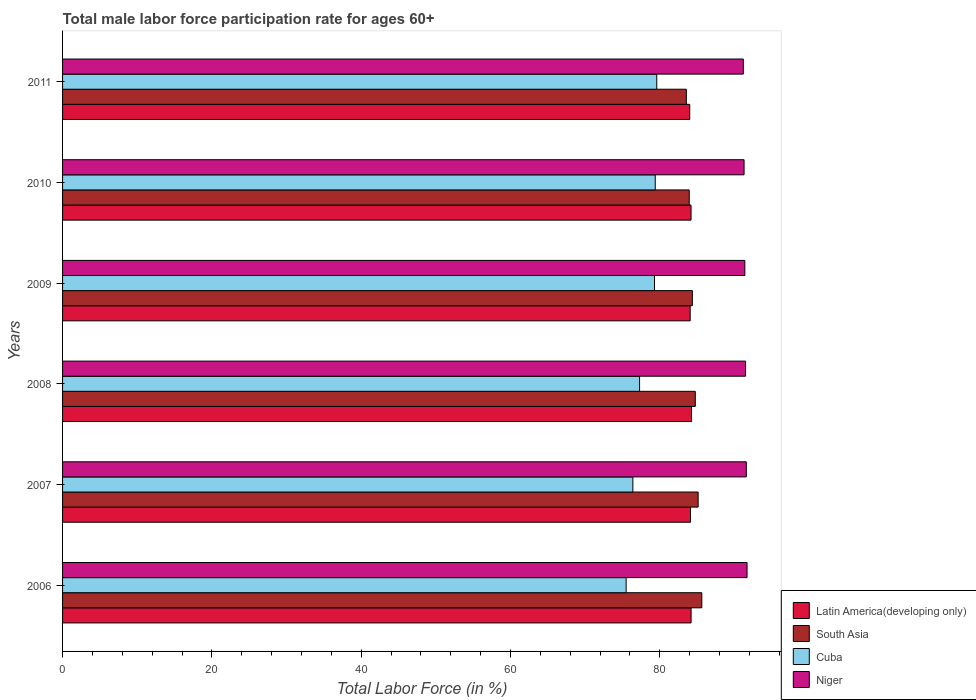Are the number of bars per tick equal to the number of legend labels?
Your answer should be compact. Yes. How many bars are there on the 1st tick from the top?
Offer a very short reply. 4. In how many cases, is the number of bars for a given year not equal to the number of legend labels?
Provide a succinct answer. 0. What is the male labor force participation rate in Latin America(developing only) in 2010?
Ensure brevity in your answer.  84.2. Across all years, what is the maximum male labor force participation rate in Latin America(developing only)?
Your answer should be compact. 84.26. Across all years, what is the minimum male labor force participation rate in Latin America(developing only)?
Give a very brief answer. 84.02. In which year was the male labor force participation rate in Niger minimum?
Your answer should be very brief. 2011. What is the total male labor force participation rate in Cuba in the graph?
Provide a succinct answer. 467.5. What is the difference between the male labor force participation rate in South Asia in 2006 and that in 2007?
Offer a terse response. 0.49. What is the difference between the male labor force participation rate in Latin America(developing only) in 2010 and the male labor force participation rate in Cuba in 2008?
Offer a terse response. 6.9. What is the average male labor force participation rate in Cuba per year?
Offer a very short reply. 77.92. In the year 2009, what is the difference between the male labor force participation rate in Cuba and male labor force participation rate in Latin America(developing only)?
Your answer should be compact. -4.78. What is the ratio of the male labor force participation rate in Niger in 2007 to that in 2010?
Ensure brevity in your answer.  1. Is the male labor force participation rate in South Asia in 2009 less than that in 2010?
Provide a succinct answer. No. Is the difference between the male labor force participation rate in Cuba in 2008 and 2011 greater than the difference between the male labor force participation rate in Latin America(developing only) in 2008 and 2011?
Keep it short and to the point. No. What is the difference between the highest and the second highest male labor force participation rate in Cuba?
Give a very brief answer. 0.2. What is the difference between the highest and the lowest male labor force participation rate in South Asia?
Your answer should be compact. 2.07. In how many years, is the male labor force participation rate in South Asia greater than the average male labor force participation rate in South Asia taken over all years?
Your answer should be very brief. 3. Is it the case that in every year, the sum of the male labor force participation rate in Niger and male labor force participation rate in South Asia is greater than the sum of male labor force participation rate in Latin America(developing only) and male labor force participation rate in Cuba?
Offer a very short reply. Yes. What does the 3rd bar from the top in 2006 represents?
Offer a terse response. South Asia. What does the 1st bar from the bottom in 2011 represents?
Your response must be concise. Latin America(developing only). Are all the bars in the graph horizontal?
Provide a short and direct response. Yes. Does the graph contain any zero values?
Your answer should be compact. No. Where does the legend appear in the graph?
Give a very brief answer. Bottom right. How many legend labels are there?
Your response must be concise. 4. How are the legend labels stacked?
Your answer should be compact. Vertical. What is the title of the graph?
Give a very brief answer. Total male labor force participation rate for ages 60+. Does "Kazakhstan" appear as one of the legend labels in the graph?
Offer a terse response. No. What is the label or title of the Y-axis?
Your response must be concise. Years. What is the Total Labor Force (in %) in Latin America(developing only) in 2006?
Give a very brief answer. 84.2. What is the Total Labor Force (in %) in South Asia in 2006?
Offer a very short reply. 85.64. What is the Total Labor Force (in %) in Cuba in 2006?
Your answer should be very brief. 75.5. What is the Total Labor Force (in %) of Niger in 2006?
Ensure brevity in your answer.  91.7. What is the Total Labor Force (in %) in Latin America(developing only) in 2007?
Give a very brief answer. 84.13. What is the Total Labor Force (in %) in South Asia in 2007?
Provide a short and direct response. 85.14. What is the Total Labor Force (in %) of Cuba in 2007?
Keep it short and to the point. 76.4. What is the Total Labor Force (in %) in Niger in 2007?
Give a very brief answer. 91.6. What is the Total Labor Force (in %) of Latin America(developing only) in 2008?
Your response must be concise. 84.26. What is the Total Labor Force (in %) of South Asia in 2008?
Make the answer very short. 84.77. What is the Total Labor Force (in %) of Cuba in 2008?
Offer a terse response. 77.3. What is the Total Labor Force (in %) in Niger in 2008?
Make the answer very short. 91.5. What is the Total Labor Force (in %) of Latin America(developing only) in 2009?
Keep it short and to the point. 84.08. What is the Total Labor Force (in %) of South Asia in 2009?
Your response must be concise. 84.37. What is the Total Labor Force (in %) in Cuba in 2009?
Offer a very short reply. 79.3. What is the Total Labor Force (in %) of Niger in 2009?
Provide a short and direct response. 91.4. What is the Total Labor Force (in %) of Latin America(developing only) in 2010?
Offer a terse response. 84.2. What is the Total Labor Force (in %) in South Asia in 2010?
Provide a succinct answer. 83.95. What is the Total Labor Force (in %) of Cuba in 2010?
Keep it short and to the point. 79.4. What is the Total Labor Force (in %) in Niger in 2010?
Offer a terse response. 91.3. What is the Total Labor Force (in %) in Latin America(developing only) in 2011?
Your answer should be compact. 84.02. What is the Total Labor Force (in %) in South Asia in 2011?
Offer a terse response. 83.57. What is the Total Labor Force (in %) of Cuba in 2011?
Provide a succinct answer. 79.6. What is the Total Labor Force (in %) of Niger in 2011?
Give a very brief answer. 91.2. Across all years, what is the maximum Total Labor Force (in %) of Latin America(developing only)?
Your answer should be compact. 84.26. Across all years, what is the maximum Total Labor Force (in %) of South Asia?
Keep it short and to the point. 85.64. Across all years, what is the maximum Total Labor Force (in %) of Cuba?
Offer a terse response. 79.6. Across all years, what is the maximum Total Labor Force (in %) of Niger?
Give a very brief answer. 91.7. Across all years, what is the minimum Total Labor Force (in %) of Latin America(developing only)?
Your answer should be compact. 84.02. Across all years, what is the minimum Total Labor Force (in %) of South Asia?
Your answer should be compact. 83.57. Across all years, what is the minimum Total Labor Force (in %) of Cuba?
Offer a terse response. 75.5. Across all years, what is the minimum Total Labor Force (in %) in Niger?
Your answer should be very brief. 91.2. What is the total Total Labor Force (in %) in Latin America(developing only) in the graph?
Provide a succinct answer. 504.88. What is the total Total Labor Force (in %) in South Asia in the graph?
Offer a terse response. 507.44. What is the total Total Labor Force (in %) in Cuba in the graph?
Ensure brevity in your answer.  467.5. What is the total Total Labor Force (in %) in Niger in the graph?
Ensure brevity in your answer.  548.7. What is the difference between the Total Labor Force (in %) in Latin America(developing only) in 2006 and that in 2007?
Offer a very short reply. 0.08. What is the difference between the Total Labor Force (in %) in South Asia in 2006 and that in 2007?
Make the answer very short. 0.49. What is the difference between the Total Labor Force (in %) of Cuba in 2006 and that in 2007?
Offer a terse response. -0.9. What is the difference between the Total Labor Force (in %) of Niger in 2006 and that in 2007?
Provide a short and direct response. 0.1. What is the difference between the Total Labor Force (in %) in Latin America(developing only) in 2006 and that in 2008?
Your response must be concise. -0.05. What is the difference between the Total Labor Force (in %) in South Asia in 2006 and that in 2008?
Keep it short and to the point. 0.87. What is the difference between the Total Labor Force (in %) in Latin America(developing only) in 2006 and that in 2009?
Offer a very short reply. 0.12. What is the difference between the Total Labor Force (in %) of South Asia in 2006 and that in 2009?
Offer a very short reply. 1.27. What is the difference between the Total Labor Force (in %) of Latin America(developing only) in 2006 and that in 2010?
Your answer should be compact. 0.01. What is the difference between the Total Labor Force (in %) of South Asia in 2006 and that in 2010?
Keep it short and to the point. 1.68. What is the difference between the Total Labor Force (in %) of Cuba in 2006 and that in 2010?
Provide a short and direct response. -3.9. What is the difference between the Total Labor Force (in %) in Latin America(developing only) in 2006 and that in 2011?
Provide a short and direct response. 0.18. What is the difference between the Total Labor Force (in %) of South Asia in 2006 and that in 2011?
Offer a terse response. 2.07. What is the difference between the Total Labor Force (in %) in Niger in 2006 and that in 2011?
Your answer should be compact. 0.5. What is the difference between the Total Labor Force (in %) of Latin America(developing only) in 2007 and that in 2008?
Provide a succinct answer. -0.13. What is the difference between the Total Labor Force (in %) of South Asia in 2007 and that in 2008?
Offer a terse response. 0.38. What is the difference between the Total Labor Force (in %) in Cuba in 2007 and that in 2008?
Your response must be concise. -0.9. What is the difference between the Total Labor Force (in %) of Latin America(developing only) in 2007 and that in 2009?
Provide a short and direct response. 0.05. What is the difference between the Total Labor Force (in %) of South Asia in 2007 and that in 2009?
Your answer should be very brief. 0.77. What is the difference between the Total Labor Force (in %) in Cuba in 2007 and that in 2009?
Make the answer very short. -2.9. What is the difference between the Total Labor Force (in %) in Niger in 2007 and that in 2009?
Make the answer very short. 0.2. What is the difference between the Total Labor Force (in %) of Latin America(developing only) in 2007 and that in 2010?
Provide a succinct answer. -0.07. What is the difference between the Total Labor Force (in %) of South Asia in 2007 and that in 2010?
Your response must be concise. 1.19. What is the difference between the Total Labor Force (in %) in Niger in 2007 and that in 2010?
Your answer should be very brief. 0.3. What is the difference between the Total Labor Force (in %) in Latin America(developing only) in 2007 and that in 2011?
Keep it short and to the point. 0.11. What is the difference between the Total Labor Force (in %) in South Asia in 2007 and that in 2011?
Make the answer very short. 1.58. What is the difference between the Total Labor Force (in %) in Cuba in 2007 and that in 2011?
Your answer should be very brief. -3.2. What is the difference between the Total Labor Force (in %) of Latin America(developing only) in 2008 and that in 2009?
Give a very brief answer. 0.18. What is the difference between the Total Labor Force (in %) in South Asia in 2008 and that in 2009?
Your response must be concise. 0.39. What is the difference between the Total Labor Force (in %) of Cuba in 2008 and that in 2009?
Give a very brief answer. -2. What is the difference between the Total Labor Force (in %) in Niger in 2008 and that in 2009?
Give a very brief answer. 0.1. What is the difference between the Total Labor Force (in %) of Latin America(developing only) in 2008 and that in 2010?
Make the answer very short. 0.06. What is the difference between the Total Labor Force (in %) in South Asia in 2008 and that in 2010?
Offer a terse response. 0.81. What is the difference between the Total Labor Force (in %) in Cuba in 2008 and that in 2010?
Provide a short and direct response. -2.1. What is the difference between the Total Labor Force (in %) of Niger in 2008 and that in 2010?
Ensure brevity in your answer.  0.2. What is the difference between the Total Labor Force (in %) of Latin America(developing only) in 2008 and that in 2011?
Your response must be concise. 0.24. What is the difference between the Total Labor Force (in %) in South Asia in 2008 and that in 2011?
Offer a terse response. 1.2. What is the difference between the Total Labor Force (in %) in Niger in 2008 and that in 2011?
Make the answer very short. 0.3. What is the difference between the Total Labor Force (in %) of Latin America(developing only) in 2009 and that in 2010?
Ensure brevity in your answer.  -0.12. What is the difference between the Total Labor Force (in %) of South Asia in 2009 and that in 2010?
Your answer should be compact. 0.42. What is the difference between the Total Labor Force (in %) in Cuba in 2009 and that in 2010?
Make the answer very short. -0.1. What is the difference between the Total Labor Force (in %) of Latin America(developing only) in 2009 and that in 2011?
Your response must be concise. 0.06. What is the difference between the Total Labor Force (in %) in South Asia in 2009 and that in 2011?
Keep it short and to the point. 0.8. What is the difference between the Total Labor Force (in %) in Latin America(developing only) in 2010 and that in 2011?
Offer a terse response. 0.18. What is the difference between the Total Labor Force (in %) of South Asia in 2010 and that in 2011?
Your answer should be very brief. 0.39. What is the difference between the Total Labor Force (in %) in Niger in 2010 and that in 2011?
Offer a terse response. 0.1. What is the difference between the Total Labor Force (in %) in Latin America(developing only) in 2006 and the Total Labor Force (in %) in South Asia in 2007?
Provide a succinct answer. -0.94. What is the difference between the Total Labor Force (in %) of Latin America(developing only) in 2006 and the Total Labor Force (in %) of Cuba in 2007?
Keep it short and to the point. 7.8. What is the difference between the Total Labor Force (in %) in Latin America(developing only) in 2006 and the Total Labor Force (in %) in Niger in 2007?
Give a very brief answer. -7.4. What is the difference between the Total Labor Force (in %) in South Asia in 2006 and the Total Labor Force (in %) in Cuba in 2007?
Give a very brief answer. 9.24. What is the difference between the Total Labor Force (in %) of South Asia in 2006 and the Total Labor Force (in %) of Niger in 2007?
Your answer should be compact. -5.96. What is the difference between the Total Labor Force (in %) of Cuba in 2006 and the Total Labor Force (in %) of Niger in 2007?
Offer a terse response. -16.1. What is the difference between the Total Labor Force (in %) in Latin America(developing only) in 2006 and the Total Labor Force (in %) in South Asia in 2008?
Make the answer very short. -0.56. What is the difference between the Total Labor Force (in %) of Latin America(developing only) in 2006 and the Total Labor Force (in %) of Cuba in 2008?
Your answer should be compact. 6.9. What is the difference between the Total Labor Force (in %) in Latin America(developing only) in 2006 and the Total Labor Force (in %) in Niger in 2008?
Give a very brief answer. -7.3. What is the difference between the Total Labor Force (in %) of South Asia in 2006 and the Total Labor Force (in %) of Cuba in 2008?
Keep it short and to the point. 8.34. What is the difference between the Total Labor Force (in %) in South Asia in 2006 and the Total Labor Force (in %) in Niger in 2008?
Your answer should be compact. -5.86. What is the difference between the Total Labor Force (in %) in Cuba in 2006 and the Total Labor Force (in %) in Niger in 2008?
Provide a succinct answer. -16. What is the difference between the Total Labor Force (in %) of Latin America(developing only) in 2006 and the Total Labor Force (in %) of South Asia in 2009?
Ensure brevity in your answer.  -0.17. What is the difference between the Total Labor Force (in %) in Latin America(developing only) in 2006 and the Total Labor Force (in %) in Cuba in 2009?
Provide a short and direct response. 4.9. What is the difference between the Total Labor Force (in %) of Latin America(developing only) in 2006 and the Total Labor Force (in %) of Niger in 2009?
Keep it short and to the point. -7.2. What is the difference between the Total Labor Force (in %) of South Asia in 2006 and the Total Labor Force (in %) of Cuba in 2009?
Give a very brief answer. 6.34. What is the difference between the Total Labor Force (in %) in South Asia in 2006 and the Total Labor Force (in %) in Niger in 2009?
Ensure brevity in your answer.  -5.76. What is the difference between the Total Labor Force (in %) in Cuba in 2006 and the Total Labor Force (in %) in Niger in 2009?
Ensure brevity in your answer.  -15.9. What is the difference between the Total Labor Force (in %) of Latin America(developing only) in 2006 and the Total Labor Force (in %) of South Asia in 2010?
Your answer should be compact. 0.25. What is the difference between the Total Labor Force (in %) of Latin America(developing only) in 2006 and the Total Labor Force (in %) of Cuba in 2010?
Keep it short and to the point. 4.8. What is the difference between the Total Labor Force (in %) of Latin America(developing only) in 2006 and the Total Labor Force (in %) of Niger in 2010?
Your response must be concise. -7.1. What is the difference between the Total Labor Force (in %) in South Asia in 2006 and the Total Labor Force (in %) in Cuba in 2010?
Give a very brief answer. 6.24. What is the difference between the Total Labor Force (in %) in South Asia in 2006 and the Total Labor Force (in %) in Niger in 2010?
Offer a very short reply. -5.66. What is the difference between the Total Labor Force (in %) of Cuba in 2006 and the Total Labor Force (in %) of Niger in 2010?
Your response must be concise. -15.8. What is the difference between the Total Labor Force (in %) in Latin America(developing only) in 2006 and the Total Labor Force (in %) in South Asia in 2011?
Make the answer very short. 0.64. What is the difference between the Total Labor Force (in %) in Latin America(developing only) in 2006 and the Total Labor Force (in %) in Cuba in 2011?
Your answer should be very brief. 4.6. What is the difference between the Total Labor Force (in %) of Latin America(developing only) in 2006 and the Total Labor Force (in %) of Niger in 2011?
Offer a very short reply. -7. What is the difference between the Total Labor Force (in %) in South Asia in 2006 and the Total Labor Force (in %) in Cuba in 2011?
Offer a terse response. 6.04. What is the difference between the Total Labor Force (in %) of South Asia in 2006 and the Total Labor Force (in %) of Niger in 2011?
Offer a terse response. -5.56. What is the difference between the Total Labor Force (in %) of Cuba in 2006 and the Total Labor Force (in %) of Niger in 2011?
Offer a very short reply. -15.7. What is the difference between the Total Labor Force (in %) of Latin America(developing only) in 2007 and the Total Labor Force (in %) of South Asia in 2008?
Your answer should be very brief. -0.64. What is the difference between the Total Labor Force (in %) in Latin America(developing only) in 2007 and the Total Labor Force (in %) in Cuba in 2008?
Provide a short and direct response. 6.83. What is the difference between the Total Labor Force (in %) of Latin America(developing only) in 2007 and the Total Labor Force (in %) of Niger in 2008?
Ensure brevity in your answer.  -7.37. What is the difference between the Total Labor Force (in %) in South Asia in 2007 and the Total Labor Force (in %) in Cuba in 2008?
Keep it short and to the point. 7.84. What is the difference between the Total Labor Force (in %) of South Asia in 2007 and the Total Labor Force (in %) of Niger in 2008?
Provide a succinct answer. -6.36. What is the difference between the Total Labor Force (in %) in Cuba in 2007 and the Total Labor Force (in %) in Niger in 2008?
Give a very brief answer. -15.1. What is the difference between the Total Labor Force (in %) of Latin America(developing only) in 2007 and the Total Labor Force (in %) of South Asia in 2009?
Ensure brevity in your answer.  -0.25. What is the difference between the Total Labor Force (in %) of Latin America(developing only) in 2007 and the Total Labor Force (in %) of Cuba in 2009?
Give a very brief answer. 4.83. What is the difference between the Total Labor Force (in %) in Latin America(developing only) in 2007 and the Total Labor Force (in %) in Niger in 2009?
Offer a terse response. -7.27. What is the difference between the Total Labor Force (in %) of South Asia in 2007 and the Total Labor Force (in %) of Cuba in 2009?
Make the answer very short. 5.84. What is the difference between the Total Labor Force (in %) of South Asia in 2007 and the Total Labor Force (in %) of Niger in 2009?
Provide a short and direct response. -6.25. What is the difference between the Total Labor Force (in %) of Latin America(developing only) in 2007 and the Total Labor Force (in %) of South Asia in 2010?
Provide a short and direct response. 0.17. What is the difference between the Total Labor Force (in %) in Latin America(developing only) in 2007 and the Total Labor Force (in %) in Cuba in 2010?
Offer a terse response. 4.73. What is the difference between the Total Labor Force (in %) in Latin America(developing only) in 2007 and the Total Labor Force (in %) in Niger in 2010?
Ensure brevity in your answer.  -7.17. What is the difference between the Total Labor Force (in %) in South Asia in 2007 and the Total Labor Force (in %) in Cuba in 2010?
Keep it short and to the point. 5.75. What is the difference between the Total Labor Force (in %) of South Asia in 2007 and the Total Labor Force (in %) of Niger in 2010?
Offer a terse response. -6.16. What is the difference between the Total Labor Force (in %) in Cuba in 2007 and the Total Labor Force (in %) in Niger in 2010?
Keep it short and to the point. -14.9. What is the difference between the Total Labor Force (in %) of Latin America(developing only) in 2007 and the Total Labor Force (in %) of South Asia in 2011?
Ensure brevity in your answer.  0.56. What is the difference between the Total Labor Force (in %) of Latin America(developing only) in 2007 and the Total Labor Force (in %) of Cuba in 2011?
Keep it short and to the point. 4.53. What is the difference between the Total Labor Force (in %) in Latin America(developing only) in 2007 and the Total Labor Force (in %) in Niger in 2011?
Provide a succinct answer. -7.07. What is the difference between the Total Labor Force (in %) of South Asia in 2007 and the Total Labor Force (in %) of Cuba in 2011?
Your answer should be very brief. 5.54. What is the difference between the Total Labor Force (in %) of South Asia in 2007 and the Total Labor Force (in %) of Niger in 2011?
Your answer should be very brief. -6.05. What is the difference between the Total Labor Force (in %) of Cuba in 2007 and the Total Labor Force (in %) of Niger in 2011?
Make the answer very short. -14.8. What is the difference between the Total Labor Force (in %) of Latin America(developing only) in 2008 and the Total Labor Force (in %) of South Asia in 2009?
Offer a very short reply. -0.11. What is the difference between the Total Labor Force (in %) in Latin America(developing only) in 2008 and the Total Labor Force (in %) in Cuba in 2009?
Give a very brief answer. 4.96. What is the difference between the Total Labor Force (in %) of Latin America(developing only) in 2008 and the Total Labor Force (in %) of Niger in 2009?
Make the answer very short. -7.14. What is the difference between the Total Labor Force (in %) in South Asia in 2008 and the Total Labor Force (in %) in Cuba in 2009?
Make the answer very short. 5.47. What is the difference between the Total Labor Force (in %) in South Asia in 2008 and the Total Labor Force (in %) in Niger in 2009?
Make the answer very short. -6.63. What is the difference between the Total Labor Force (in %) of Cuba in 2008 and the Total Labor Force (in %) of Niger in 2009?
Your answer should be compact. -14.1. What is the difference between the Total Labor Force (in %) in Latin America(developing only) in 2008 and the Total Labor Force (in %) in South Asia in 2010?
Keep it short and to the point. 0.3. What is the difference between the Total Labor Force (in %) in Latin America(developing only) in 2008 and the Total Labor Force (in %) in Cuba in 2010?
Make the answer very short. 4.86. What is the difference between the Total Labor Force (in %) in Latin America(developing only) in 2008 and the Total Labor Force (in %) in Niger in 2010?
Your answer should be compact. -7.04. What is the difference between the Total Labor Force (in %) of South Asia in 2008 and the Total Labor Force (in %) of Cuba in 2010?
Provide a succinct answer. 5.37. What is the difference between the Total Labor Force (in %) in South Asia in 2008 and the Total Labor Force (in %) in Niger in 2010?
Your answer should be very brief. -6.53. What is the difference between the Total Labor Force (in %) of Latin America(developing only) in 2008 and the Total Labor Force (in %) of South Asia in 2011?
Your answer should be compact. 0.69. What is the difference between the Total Labor Force (in %) of Latin America(developing only) in 2008 and the Total Labor Force (in %) of Cuba in 2011?
Your answer should be very brief. 4.66. What is the difference between the Total Labor Force (in %) in Latin America(developing only) in 2008 and the Total Labor Force (in %) in Niger in 2011?
Provide a succinct answer. -6.94. What is the difference between the Total Labor Force (in %) of South Asia in 2008 and the Total Labor Force (in %) of Cuba in 2011?
Your response must be concise. 5.17. What is the difference between the Total Labor Force (in %) in South Asia in 2008 and the Total Labor Force (in %) in Niger in 2011?
Keep it short and to the point. -6.43. What is the difference between the Total Labor Force (in %) of Latin America(developing only) in 2009 and the Total Labor Force (in %) of South Asia in 2010?
Your answer should be compact. 0.13. What is the difference between the Total Labor Force (in %) in Latin America(developing only) in 2009 and the Total Labor Force (in %) in Cuba in 2010?
Offer a terse response. 4.68. What is the difference between the Total Labor Force (in %) of Latin America(developing only) in 2009 and the Total Labor Force (in %) of Niger in 2010?
Your answer should be very brief. -7.22. What is the difference between the Total Labor Force (in %) of South Asia in 2009 and the Total Labor Force (in %) of Cuba in 2010?
Ensure brevity in your answer.  4.97. What is the difference between the Total Labor Force (in %) of South Asia in 2009 and the Total Labor Force (in %) of Niger in 2010?
Ensure brevity in your answer.  -6.93. What is the difference between the Total Labor Force (in %) in Cuba in 2009 and the Total Labor Force (in %) in Niger in 2010?
Offer a terse response. -12. What is the difference between the Total Labor Force (in %) in Latin America(developing only) in 2009 and the Total Labor Force (in %) in South Asia in 2011?
Your answer should be compact. 0.51. What is the difference between the Total Labor Force (in %) of Latin America(developing only) in 2009 and the Total Labor Force (in %) of Cuba in 2011?
Give a very brief answer. 4.48. What is the difference between the Total Labor Force (in %) of Latin America(developing only) in 2009 and the Total Labor Force (in %) of Niger in 2011?
Provide a succinct answer. -7.12. What is the difference between the Total Labor Force (in %) in South Asia in 2009 and the Total Labor Force (in %) in Cuba in 2011?
Make the answer very short. 4.77. What is the difference between the Total Labor Force (in %) in South Asia in 2009 and the Total Labor Force (in %) in Niger in 2011?
Your answer should be compact. -6.83. What is the difference between the Total Labor Force (in %) of Latin America(developing only) in 2010 and the Total Labor Force (in %) of South Asia in 2011?
Give a very brief answer. 0.63. What is the difference between the Total Labor Force (in %) of Latin America(developing only) in 2010 and the Total Labor Force (in %) of Cuba in 2011?
Offer a terse response. 4.6. What is the difference between the Total Labor Force (in %) in Latin America(developing only) in 2010 and the Total Labor Force (in %) in Niger in 2011?
Offer a terse response. -7. What is the difference between the Total Labor Force (in %) in South Asia in 2010 and the Total Labor Force (in %) in Cuba in 2011?
Offer a terse response. 4.35. What is the difference between the Total Labor Force (in %) of South Asia in 2010 and the Total Labor Force (in %) of Niger in 2011?
Your answer should be very brief. -7.25. What is the difference between the Total Labor Force (in %) of Cuba in 2010 and the Total Labor Force (in %) of Niger in 2011?
Give a very brief answer. -11.8. What is the average Total Labor Force (in %) in Latin America(developing only) per year?
Offer a terse response. 84.15. What is the average Total Labor Force (in %) of South Asia per year?
Make the answer very short. 84.57. What is the average Total Labor Force (in %) of Cuba per year?
Keep it short and to the point. 77.92. What is the average Total Labor Force (in %) in Niger per year?
Keep it short and to the point. 91.45. In the year 2006, what is the difference between the Total Labor Force (in %) of Latin America(developing only) and Total Labor Force (in %) of South Asia?
Ensure brevity in your answer.  -1.43. In the year 2006, what is the difference between the Total Labor Force (in %) of Latin America(developing only) and Total Labor Force (in %) of Cuba?
Your answer should be very brief. 8.7. In the year 2006, what is the difference between the Total Labor Force (in %) in Latin America(developing only) and Total Labor Force (in %) in Niger?
Give a very brief answer. -7.5. In the year 2006, what is the difference between the Total Labor Force (in %) of South Asia and Total Labor Force (in %) of Cuba?
Give a very brief answer. 10.14. In the year 2006, what is the difference between the Total Labor Force (in %) of South Asia and Total Labor Force (in %) of Niger?
Keep it short and to the point. -6.06. In the year 2006, what is the difference between the Total Labor Force (in %) in Cuba and Total Labor Force (in %) in Niger?
Your answer should be very brief. -16.2. In the year 2007, what is the difference between the Total Labor Force (in %) in Latin America(developing only) and Total Labor Force (in %) in South Asia?
Keep it short and to the point. -1.02. In the year 2007, what is the difference between the Total Labor Force (in %) of Latin America(developing only) and Total Labor Force (in %) of Cuba?
Your answer should be compact. 7.73. In the year 2007, what is the difference between the Total Labor Force (in %) of Latin America(developing only) and Total Labor Force (in %) of Niger?
Give a very brief answer. -7.47. In the year 2007, what is the difference between the Total Labor Force (in %) in South Asia and Total Labor Force (in %) in Cuba?
Provide a succinct answer. 8.74. In the year 2007, what is the difference between the Total Labor Force (in %) of South Asia and Total Labor Force (in %) of Niger?
Offer a very short reply. -6.46. In the year 2007, what is the difference between the Total Labor Force (in %) in Cuba and Total Labor Force (in %) in Niger?
Provide a short and direct response. -15.2. In the year 2008, what is the difference between the Total Labor Force (in %) in Latin America(developing only) and Total Labor Force (in %) in South Asia?
Provide a succinct answer. -0.51. In the year 2008, what is the difference between the Total Labor Force (in %) of Latin America(developing only) and Total Labor Force (in %) of Cuba?
Make the answer very short. 6.96. In the year 2008, what is the difference between the Total Labor Force (in %) in Latin America(developing only) and Total Labor Force (in %) in Niger?
Keep it short and to the point. -7.24. In the year 2008, what is the difference between the Total Labor Force (in %) in South Asia and Total Labor Force (in %) in Cuba?
Offer a terse response. 7.47. In the year 2008, what is the difference between the Total Labor Force (in %) in South Asia and Total Labor Force (in %) in Niger?
Offer a terse response. -6.73. In the year 2009, what is the difference between the Total Labor Force (in %) in Latin America(developing only) and Total Labor Force (in %) in South Asia?
Keep it short and to the point. -0.29. In the year 2009, what is the difference between the Total Labor Force (in %) of Latin America(developing only) and Total Labor Force (in %) of Cuba?
Your response must be concise. 4.78. In the year 2009, what is the difference between the Total Labor Force (in %) in Latin America(developing only) and Total Labor Force (in %) in Niger?
Ensure brevity in your answer.  -7.32. In the year 2009, what is the difference between the Total Labor Force (in %) of South Asia and Total Labor Force (in %) of Cuba?
Offer a terse response. 5.07. In the year 2009, what is the difference between the Total Labor Force (in %) in South Asia and Total Labor Force (in %) in Niger?
Your response must be concise. -7.03. In the year 2009, what is the difference between the Total Labor Force (in %) in Cuba and Total Labor Force (in %) in Niger?
Give a very brief answer. -12.1. In the year 2010, what is the difference between the Total Labor Force (in %) in Latin America(developing only) and Total Labor Force (in %) in South Asia?
Make the answer very short. 0.24. In the year 2010, what is the difference between the Total Labor Force (in %) in Latin America(developing only) and Total Labor Force (in %) in Cuba?
Give a very brief answer. 4.8. In the year 2010, what is the difference between the Total Labor Force (in %) of Latin America(developing only) and Total Labor Force (in %) of Niger?
Provide a succinct answer. -7.1. In the year 2010, what is the difference between the Total Labor Force (in %) in South Asia and Total Labor Force (in %) in Cuba?
Your answer should be compact. 4.55. In the year 2010, what is the difference between the Total Labor Force (in %) in South Asia and Total Labor Force (in %) in Niger?
Your response must be concise. -7.35. In the year 2011, what is the difference between the Total Labor Force (in %) of Latin America(developing only) and Total Labor Force (in %) of South Asia?
Offer a terse response. 0.45. In the year 2011, what is the difference between the Total Labor Force (in %) in Latin America(developing only) and Total Labor Force (in %) in Cuba?
Provide a succinct answer. 4.42. In the year 2011, what is the difference between the Total Labor Force (in %) in Latin America(developing only) and Total Labor Force (in %) in Niger?
Your answer should be compact. -7.18. In the year 2011, what is the difference between the Total Labor Force (in %) of South Asia and Total Labor Force (in %) of Cuba?
Your answer should be very brief. 3.97. In the year 2011, what is the difference between the Total Labor Force (in %) of South Asia and Total Labor Force (in %) of Niger?
Make the answer very short. -7.63. In the year 2011, what is the difference between the Total Labor Force (in %) in Cuba and Total Labor Force (in %) in Niger?
Offer a terse response. -11.6. What is the ratio of the Total Labor Force (in %) in South Asia in 2006 to that in 2007?
Your answer should be very brief. 1.01. What is the ratio of the Total Labor Force (in %) of South Asia in 2006 to that in 2008?
Your response must be concise. 1.01. What is the ratio of the Total Labor Force (in %) in Cuba in 2006 to that in 2008?
Provide a succinct answer. 0.98. What is the ratio of the Total Labor Force (in %) of Niger in 2006 to that in 2008?
Ensure brevity in your answer.  1. What is the ratio of the Total Labor Force (in %) in Latin America(developing only) in 2006 to that in 2009?
Make the answer very short. 1. What is the ratio of the Total Labor Force (in %) in South Asia in 2006 to that in 2009?
Give a very brief answer. 1.01. What is the ratio of the Total Labor Force (in %) of Cuba in 2006 to that in 2009?
Make the answer very short. 0.95. What is the ratio of the Total Labor Force (in %) of South Asia in 2006 to that in 2010?
Keep it short and to the point. 1.02. What is the ratio of the Total Labor Force (in %) of Cuba in 2006 to that in 2010?
Offer a terse response. 0.95. What is the ratio of the Total Labor Force (in %) in Niger in 2006 to that in 2010?
Provide a short and direct response. 1. What is the ratio of the Total Labor Force (in %) in South Asia in 2006 to that in 2011?
Offer a terse response. 1.02. What is the ratio of the Total Labor Force (in %) of Cuba in 2006 to that in 2011?
Your answer should be very brief. 0.95. What is the ratio of the Total Labor Force (in %) of Latin America(developing only) in 2007 to that in 2008?
Your answer should be compact. 1. What is the ratio of the Total Labor Force (in %) in Cuba in 2007 to that in 2008?
Your answer should be very brief. 0.99. What is the ratio of the Total Labor Force (in %) of South Asia in 2007 to that in 2009?
Provide a succinct answer. 1.01. What is the ratio of the Total Labor Force (in %) in Cuba in 2007 to that in 2009?
Offer a terse response. 0.96. What is the ratio of the Total Labor Force (in %) in South Asia in 2007 to that in 2010?
Keep it short and to the point. 1.01. What is the ratio of the Total Labor Force (in %) in Cuba in 2007 to that in 2010?
Your response must be concise. 0.96. What is the ratio of the Total Labor Force (in %) of Niger in 2007 to that in 2010?
Provide a short and direct response. 1. What is the ratio of the Total Labor Force (in %) of South Asia in 2007 to that in 2011?
Your response must be concise. 1.02. What is the ratio of the Total Labor Force (in %) of Cuba in 2007 to that in 2011?
Offer a very short reply. 0.96. What is the ratio of the Total Labor Force (in %) in Niger in 2007 to that in 2011?
Offer a very short reply. 1. What is the ratio of the Total Labor Force (in %) of Cuba in 2008 to that in 2009?
Provide a short and direct response. 0.97. What is the ratio of the Total Labor Force (in %) of Niger in 2008 to that in 2009?
Your answer should be very brief. 1. What is the ratio of the Total Labor Force (in %) in South Asia in 2008 to that in 2010?
Offer a terse response. 1.01. What is the ratio of the Total Labor Force (in %) in Cuba in 2008 to that in 2010?
Your response must be concise. 0.97. What is the ratio of the Total Labor Force (in %) of Latin America(developing only) in 2008 to that in 2011?
Offer a very short reply. 1. What is the ratio of the Total Labor Force (in %) of South Asia in 2008 to that in 2011?
Give a very brief answer. 1.01. What is the ratio of the Total Labor Force (in %) of Cuba in 2008 to that in 2011?
Make the answer very short. 0.97. What is the ratio of the Total Labor Force (in %) of Cuba in 2009 to that in 2010?
Provide a succinct answer. 1. What is the ratio of the Total Labor Force (in %) in Niger in 2009 to that in 2010?
Make the answer very short. 1. What is the ratio of the Total Labor Force (in %) in Latin America(developing only) in 2009 to that in 2011?
Keep it short and to the point. 1. What is the ratio of the Total Labor Force (in %) in South Asia in 2009 to that in 2011?
Your answer should be compact. 1.01. What is the ratio of the Total Labor Force (in %) of Cuba in 2009 to that in 2011?
Offer a very short reply. 1. What is the ratio of the Total Labor Force (in %) of Latin America(developing only) in 2010 to that in 2011?
Your answer should be compact. 1. What is the ratio of the Total Labor Force (in %) in Niger in 2010 to that in 2011?
Your answer should be compact. 1. What is the difference between the highest and the second highest Total Labor Force (in %) of Latin America(developing only)?
Keep it short and to the point. 0.05. What is the difference between the highest and the second highest Total Labor Force (in %) of South Asia?
Your response must be concise. 0.49. What is the difference between the highest and the second highest Total Labor Force (in %) of Cuba?
Make the answer very short. 0.2. What is the difference between the highest and the lowest Total Labor Force (in %) of Latin America(developing only)?
Keep it short and to the point. 0.24. What is the difference between the highest and the lowest Total Labor Force (in %) in South Asia?
Provide a short and direct response. 2.07. What is the difference between the highest and the lowest Total Labor Force (in %) of Niger?
Provide a succinct answer. 0.5. 